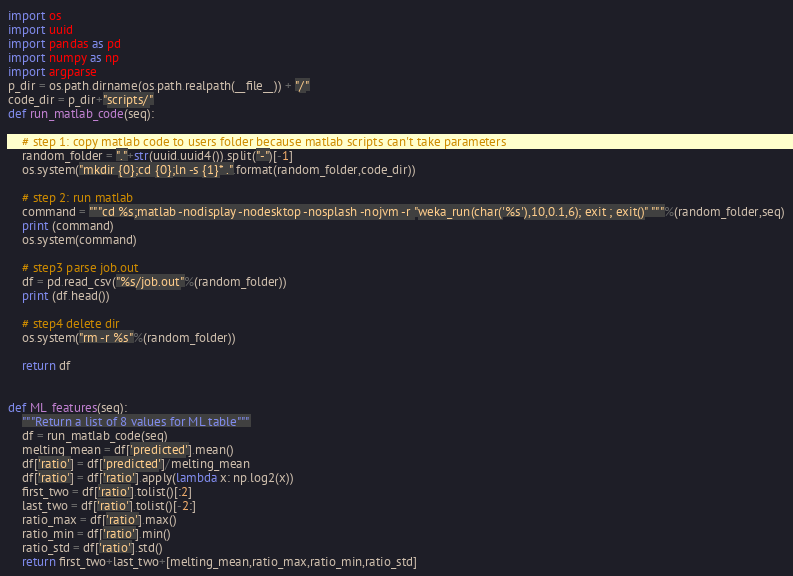Convert code to text. <code><loc_0><loc_0><loc_500><loc_500><_Python_>

import os
import uuid
import pandas as pd
import numpy as np
import argparse
p_dir = os.path.dirname(os.path.realpath(__file__)) + "/"
code_dir = p_dir+"scripts/"
def run_matlab_code(seq):
	
	# step 1: copy matlab code to users folder because matlab scripts can't take parameters
	random_folder = "."+str(uuid.uuid4()).split("-")[-1]
	os.system("mkdir {0};cd {0};ln -s {1}* .".format(random_folder,code_dir))
	
	# step 2: run matlab
	command = """cd %s;matlab -nodisplay -nodesktop -nosplash -nojvm -r "weka_run(char('%s'),10,0.1,6); exit ; exit()" """%(random_folder,seq)
	print (command)
	os.system(command)
	
	# step3 parse job.out
	df = pd.read_csv("%s/job.out"%(random_folder))
	print (df.head())
	
	# step4 delete dir
	os.system("rm -r %s"%(random_folder))
	
	return df


def ML_features(seq):
	"""Return a list of 8 values for ML table"""
	df = run_matlab_code(seq)	
	melting_mean = df['predicted'].mean()
	df['ratio'] = df['predicted']/melting_mean
	df['ratio'] = df['ratio'].apply(lambda x: np.log2(x))
	first_two = df['ratio'].tolist()[:2]
	last_two = df['ratio'].tolist()[-2:]
	ratio_max = df['ratio'].max()
	ratio_min = df['ratio'].min()
	ratio_std = df['ratio'].std()
	return first_two+last_two+[melting_mean,ratio_max,ratio_min,ratio_std]


</code> 